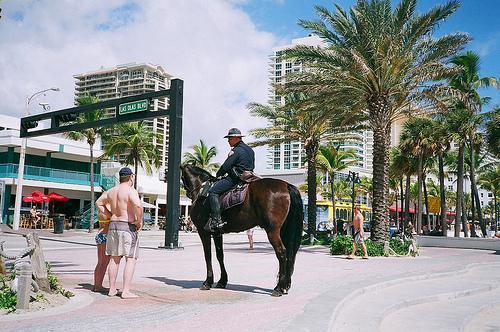How many officers are shown?
Give a very brief answer. 1. 